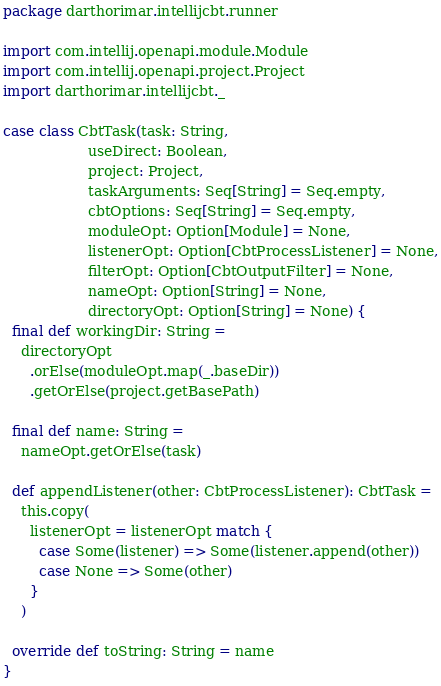<code> <loc_0><loc_0><loc_500><loc_500><_Scala_>package darthorimar.intellijcbt.runner

import com.intellij.openapi.module.Module
import com.intellij.openapi.project.Project
import darthorimar.intellijcbt._

case class CbtTask(task: String,
                   useDirect: Boolean,
                   project: Project,
                   taskArguments: Seq[String] = Seq.empty,
                   cbtOptions: Seq[String] = Seq.empty,
                   moduleOpt: Option[Module] = None,
                   listenerOpt: Option[CbtProcessListener] = None,
                   filterOpt: Option[CbtOutputFilter] = None,
                   nameOpt: Option[String] = None,
                   directoryOpt: Option[String] = None) {
  final def workingDir: String =
    directoryOpt
      .orElse(moduleOpt.map(_.baseDir))
      .getOrElse(project.getBasePath)

  final def name: String =
    nameOpt.getOrElse(task)

  def appendListener(other: CbtProcessListener): CbtTask =
    this.copy(
      listenerOpt = listenerOpt match {
        case Some(listener) => Some(listener.append(other))
        case None => Some(other)
      }
    )

  override def toString: String = name
}
</code> 